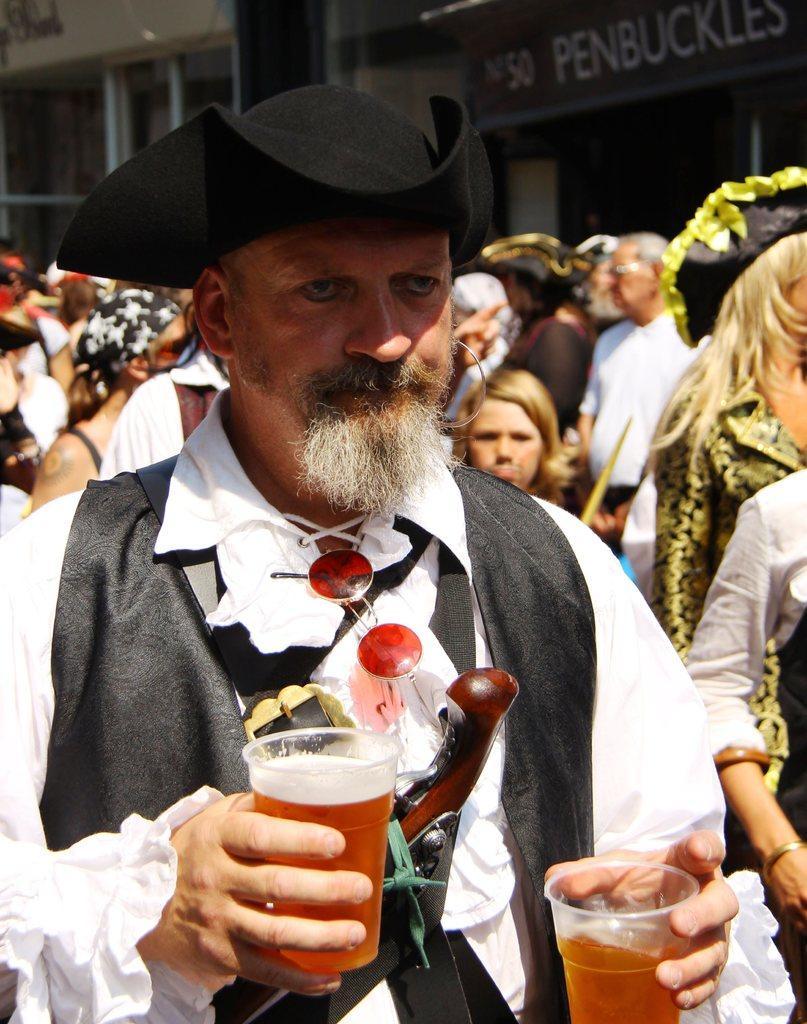Please provide a concise description of this image. In this picture a man holding two glasses of juice which is in red color and there are many people behind them. In the background there is a shop which is named as PENBUCKLES. 